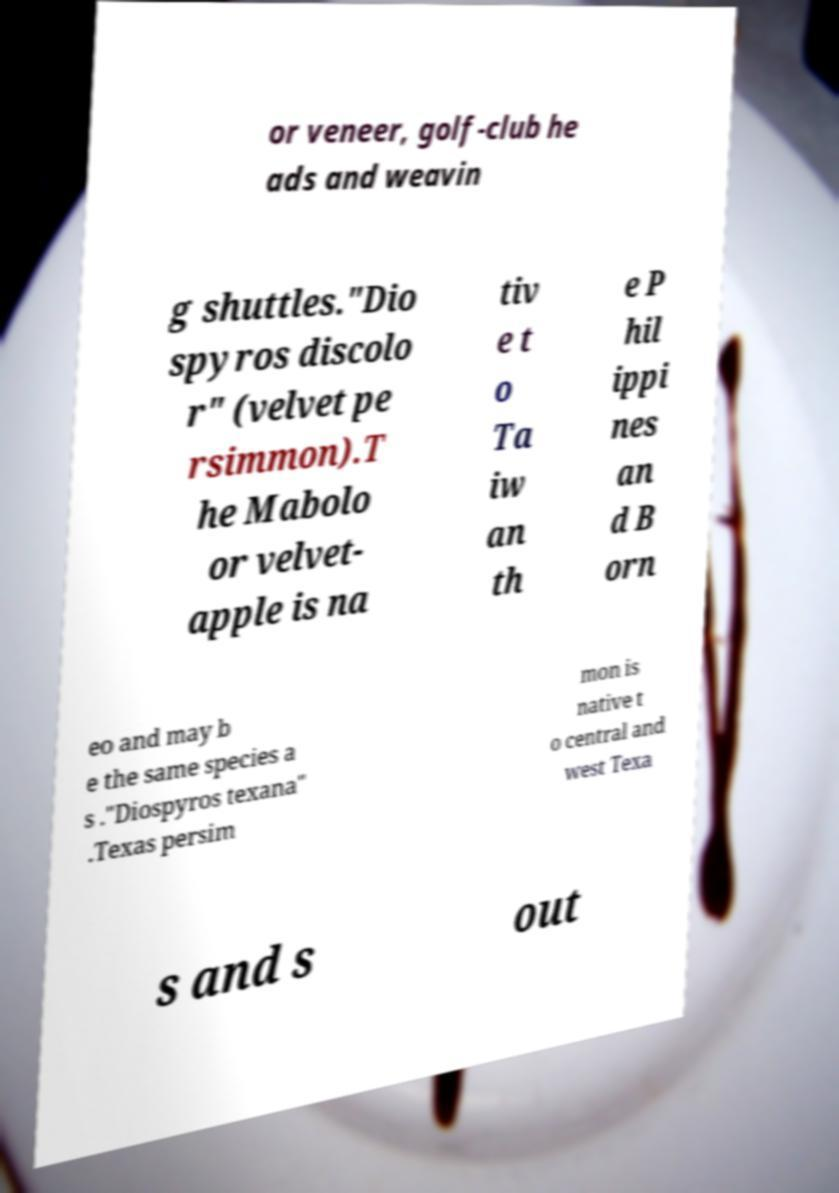For documentation purposes, I need the text within this image transcribed. Could you provide that? or veneer, golf-club he ads and weavin g shuttles."Dio spyros discolo r" (velvet pe rsimmon).T he Mabolo or velvet- apple is na tiv e t o Ta iw an th e P hil ippi nes an d B orn eo and may b e the same species a s ."Diospyros texana" .Texas persim mon is native t o central and west Texa s and s out 